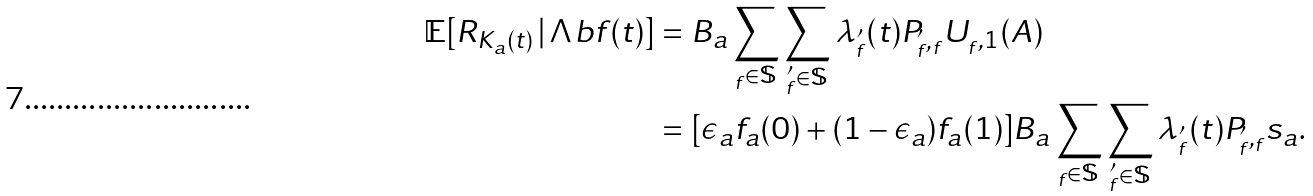Convert formula to latex. <formula><loc_0><loc_0><loc_500><loc_500>\mathbb { E } [ R _ { K _ { a } ( t ) } \, | \, \Lambda b f ( t ) ] & = B _ { a } \sum _ { _ { f } \in \mathbb { S } } \sum _ { _ { f } ^ { \prime } \in \mathbb { S } } \lambda _ { _ { f } ^ { \prime } } ( t ) P _ { _ { f } ^ { \prime } , _ { f } } U _ { _ { f } , 1 } ( A ) \\ & = [ \epsilon _ { a } f _ { a } ( 0 ) + ( 1 - \epsilon _ { a } ) f _ { a } ( 1 ) ] B _ { a } \sum _ { _ { f } \in \mathbb { S } } \sum _ { _ { f } ^ { \prime } \in \mathbb { S } } \lambda _ { _ { f } ^ { \prime } } ( t ) P _ { _ { f } ^ { \prime } , _ { f } } s _ { a } .</formula> 